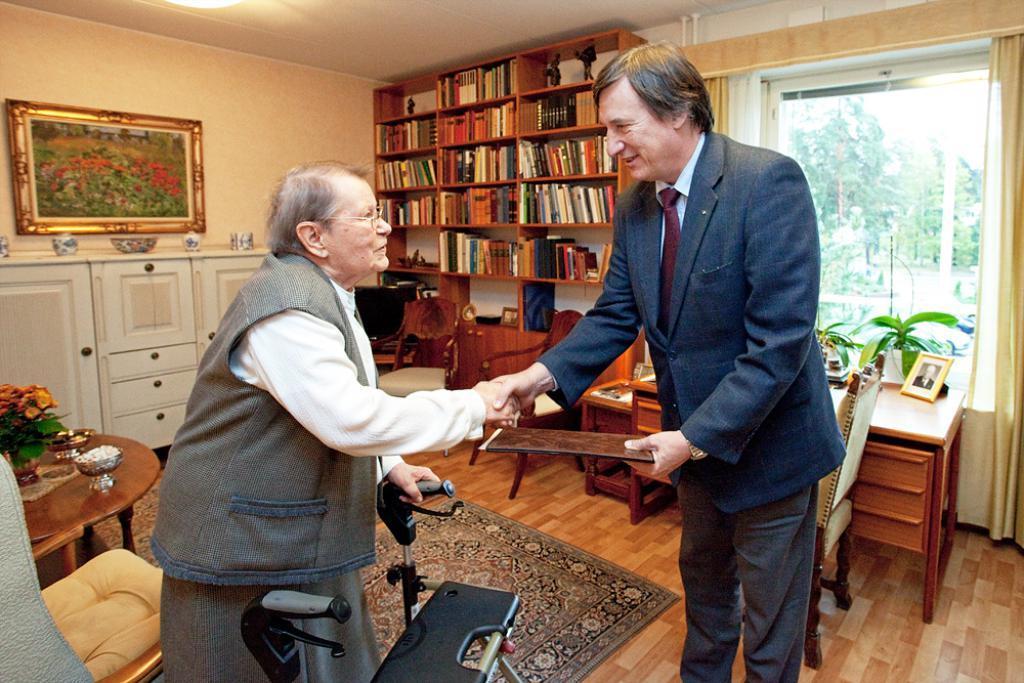In one or two sentences, can you explain what this image depicts? In this image, there are a few people holding some objects. We can see the ground with the carpet and some objects. We can also see some tables with objects like a frame and a flower pot. We can see the wall with the photo frame. We can see some shelves with objects like books. We can also see some cupboards. We can see some chairs and a view from the glass. 